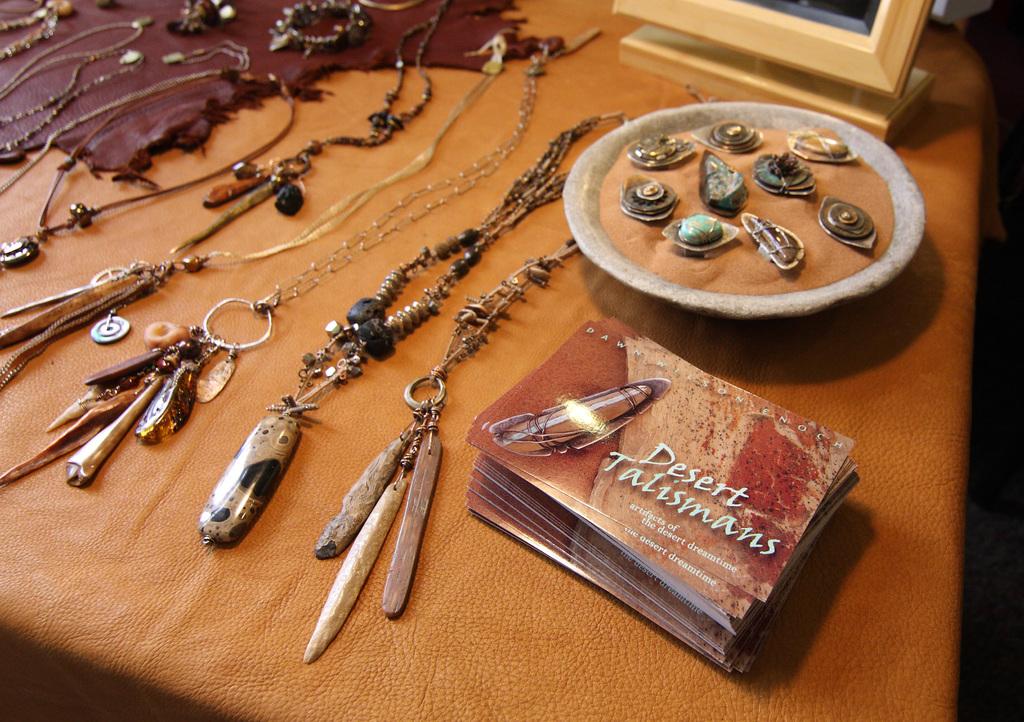What are these?
Give a very brief answer. Desert talismans. What kind of talisman's is the book about?
Offer a terse response. Desert. 